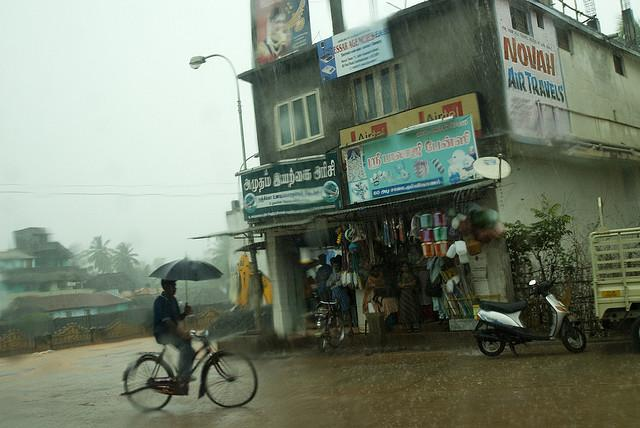Which person gets the most soaked? bicyclist 